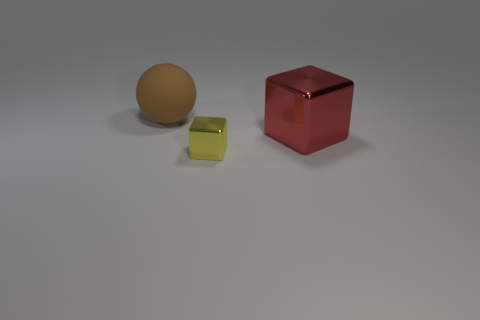Is there any other thing that is the same material as the brown thing?
Provide a short and direct response. No. Is the number of tiny cyan metallic objects greater than the number of balls?
Give a very brief answer. No. There is a large block; does it have the same color as the big object behind the red shiny cube?
Offer a terse response. No. There is a object that is both on the left side of the big red object and behind the small cube; what is its color?
Offer a terse response. Brown. How many other objects are there of the same material as the tiny yellow thing?
Your answer should be compact. 1. Are there fewer brown objects than cyan matte things?
Give a very brief answer. No. Do the tiny cube and the thing that is to the right of the yellow object have the same material?
Give a very brief answer. Yes. What is the shape of the large object that is on the left side of the big metal cube?
Your response must be concise. Sphere. Is there any other thing of the same color as the ball?
Keep it short and to the point. No. Is the number of spheres that are in front of the yellow metallic block less than the number of tiny cyan metal cylinders?
Give a very brief answer. No. 